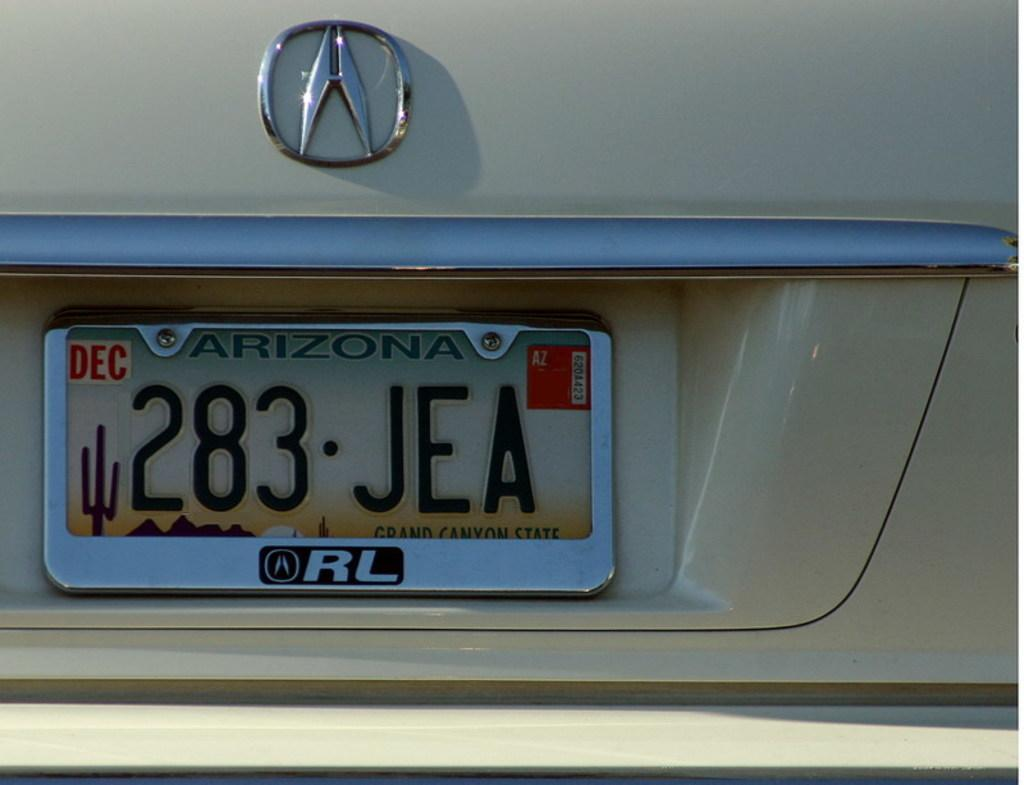<image>
Write a terse but informative summary of the picture. Arizona license plate which says 283JEA on it. 